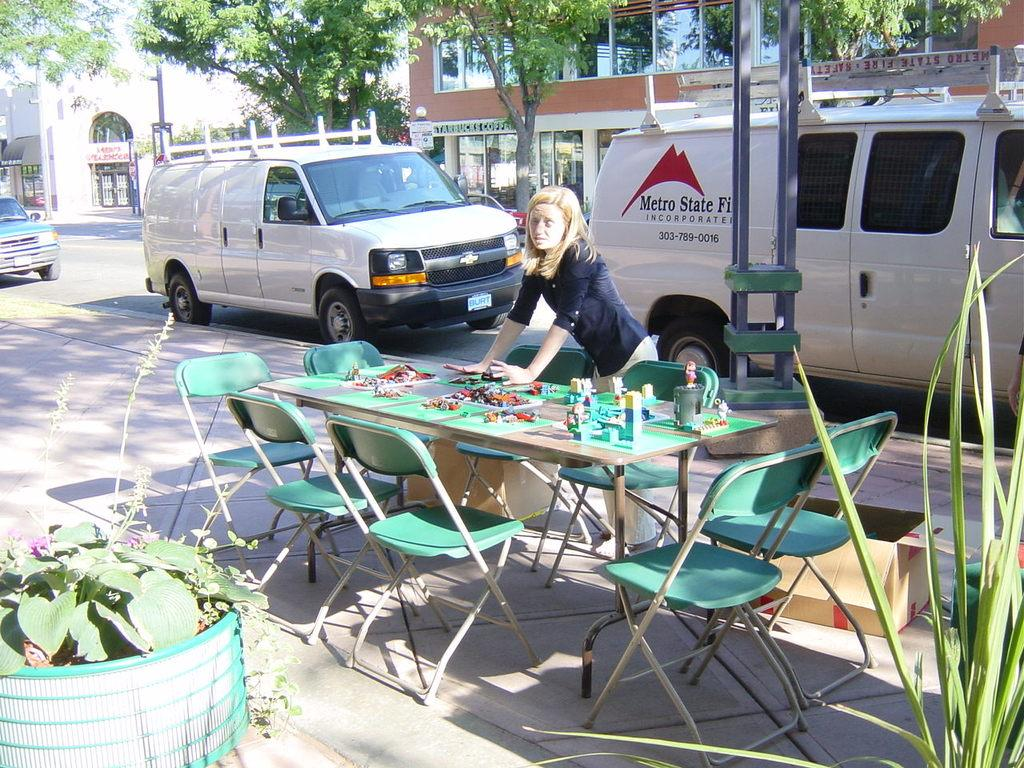<image>
Offer a succinct explanation of the picture presented. A Metro State Incorporated truck sits in front of an outdoor table 